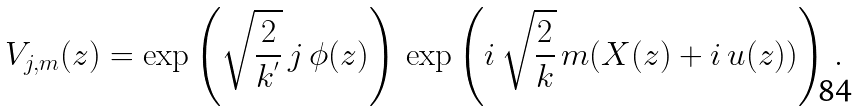Convert formula to latex. <formula><loc_0><loc_0><loc_500><loc_500>V _ { j , m } ( z ) = \exp \left ( \sqrt { \frac { 2 } { k ^ { ^ { \prime } } } } \, j \, \phi ( z ) \right ) \, \exp \left ( i \, \sqrt { \frac { 2 } { k } } \, m ( X ( z ) + i \, u ( z ) ) \right ) \, .</formula> 